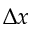Convert formula to latex. <formula><loc_0><loc_0><loc_500><loc_500>\Delta x</formula> 